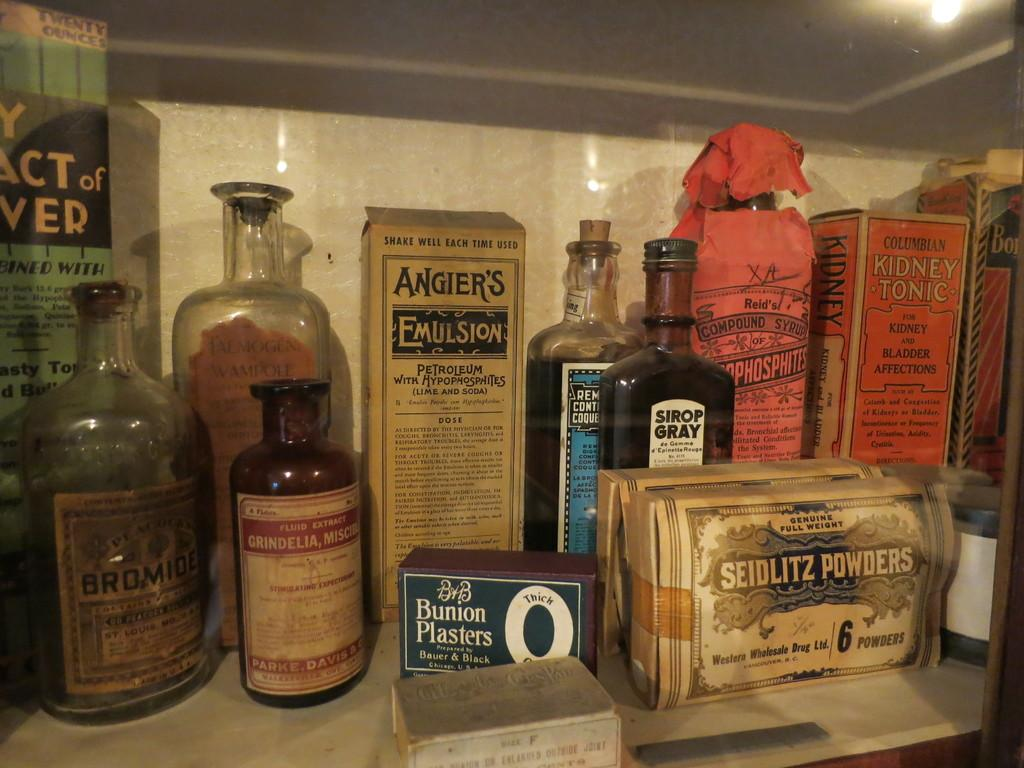<image>
Offer a succinct explanation of the picture presented. An old bottle of Sirop Gray sits with other antique bottles and containers. 